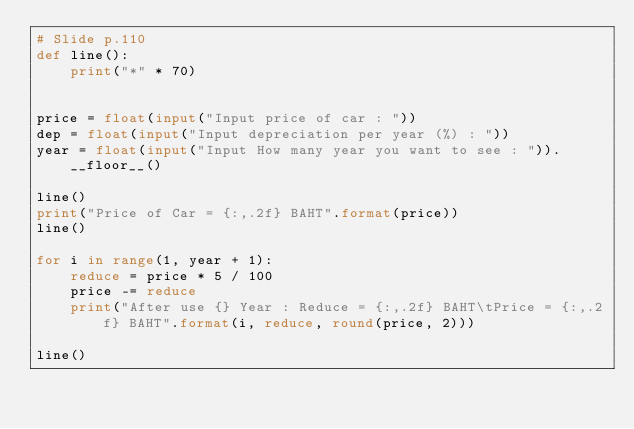<code> <loc_0><loc_0><loc_500><loc_500><_Python_># Slide p.110
def line():
    print("*" * 70)


price = float(input("Input price of car : "))
dep = float(input("Input depreciation per year (%) : "))
year = float(input("Input How many year you want to see : ")).__floor__()

line()
print("Price of Car = {:,.2f} BAHT".format(price))
line()

for i in range(1, year + 1):
    reduce = price * 5 / 100
    price -= reduce
    print("After use {} Year : Reduce = {:,.2f} BAHT\tPrice = {:,.2f} BAHT".format(i, reduce, round(price, 2)))

line()
</code> 